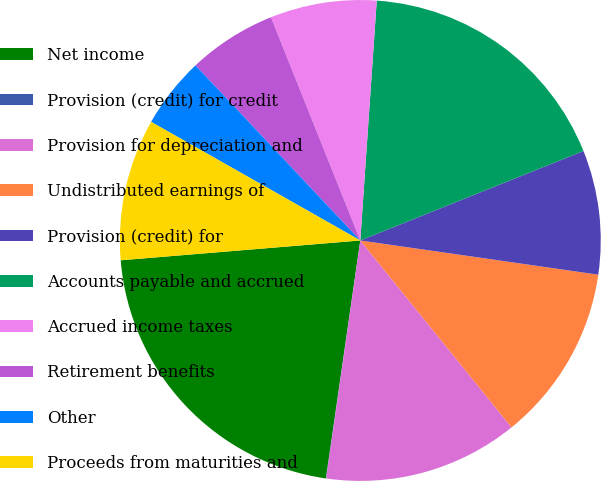<chart> <loc_0><loc_0><loc_500><loc_500><pie_chart><fcel>Net income<fcel>Provision (credit) for credit<fcel>Provision for depreciation and<fcel>Undistributed earnings of<fcel>Provision (credit) for<fcel>Accounts payable and accrued<fcel>Accrued income taxes<fcel>Retirement benefits<fcel>Other<fcel>Proceeds from maturities and<nl><fcel>21.4%<fcel>0.02%<fcel>13.09%<fcel>11.9%<fcel>8.34%<fcel>17.84%<fcel>7.15%<fcel>5.96%<fcel>4.77%<fcel>9.52%<nl></chart> 